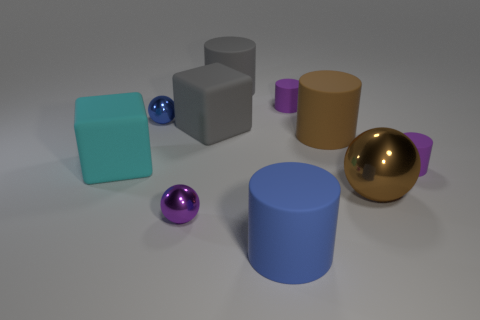Subtract all large brown matte cylinders. How many cylinders are left? 4 Subtract all blue cylinders. How many cylinders are left? 4 Subtract all red cylinders. Subtract all green spheres. How many cylinders are left? 5 Subtract all blocks. How many objects are left? 8 Subtract 1 gray cubes. How many objects are left? 9 Subtract all big brown shiny objects. Subtract all small matte cylinders. How many objects are left? 7 Add 4 large balls. How many large balls are left? 5 Add 7 spheres. How many spheres exist? 10 